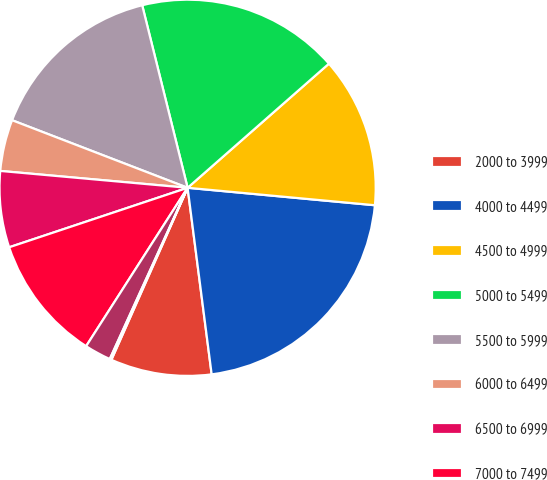<chart> <loc_0><loc_0><loc_500><loc_500><pie_chart><fcel>2000 to 3999<fcel>4000 to 4499<fcel>4500 to 4999<fcel>5000 to 5499<fcel>5500 to 5999<fcel>6000 to 6499<fcel>6500 to 6999<fcel>7000 to 7499<fcel>7500 to 7999<fcel>8000 to 8292<nl><fcel>8.68%<fcel>21.48%<fcel>12.95%<fcel>17.41%<fcel>15.27%<fcel>4.42%<fcel>6.55%<fcel>10.81%<fcel>2.28%<fcel>0.15%<nl></chart> 